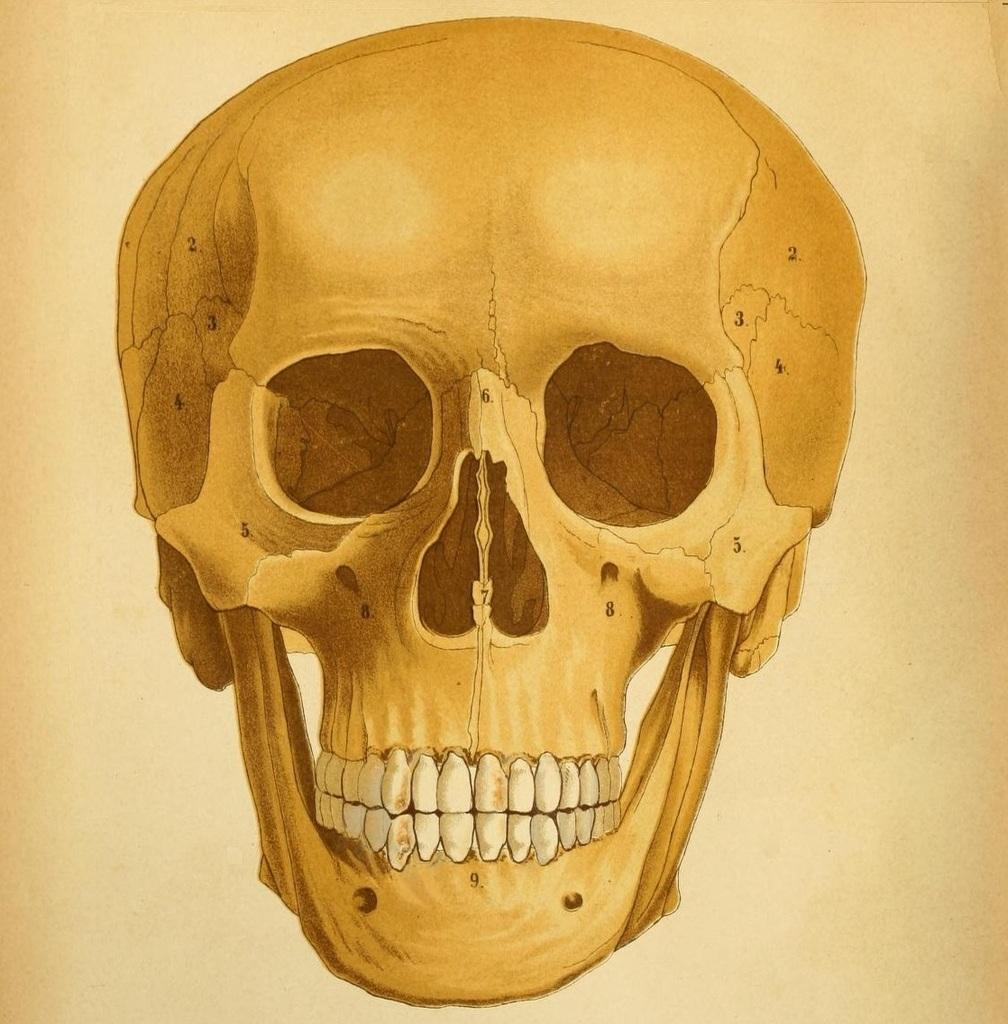What is depicted on the poster in the image? The poster contains a skull. Are there any additional details on the poster? Yes, the skull is labeled with numbers. What type of wire can be seen connecting the skull to the trees in the image? There are no trees or wires present in the image; it only features a poster with a skull labeled with numbers. 